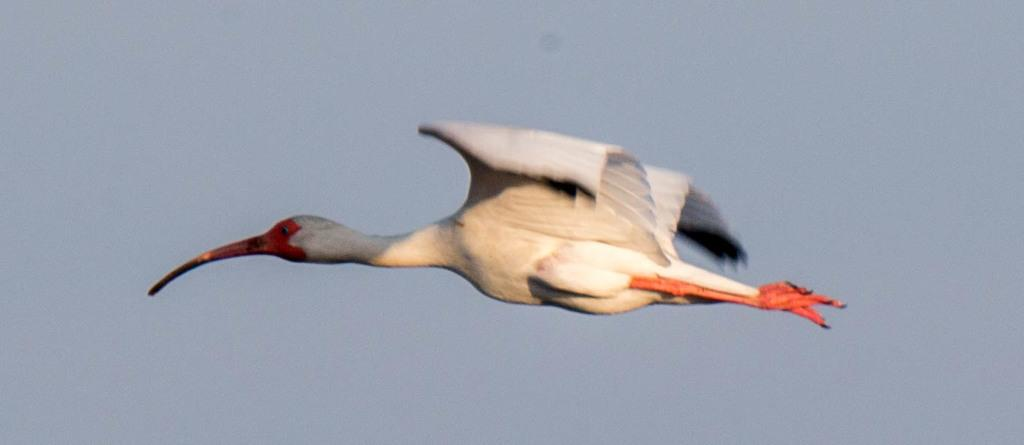What type of animal is in the image? There is a white color bird in the image. What is the bird doing in the image? The bird is flying in the air. In which direction is the bird flying? The bird is flying towards the left side. What can be seen in the background of the image? The sky is visible in the background of the image. What type of liquid can be seen in the image? There is no liquid present in the image; it features a bird flying in the air. Is there a letter being carried by the bird in the image? There is no letter present in the image; it only shows a bird flying in the air. 